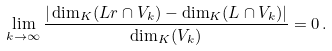Convert formula to latex. <formula><loc_0><loc_0><loc_500><loc_500>\lim _ { k \to \infty } \frac { | \dim _ { K } ( L r \cap V _ { k } ) - \dim _ { K } ( L \cap V _ { k } ) | } { \dim _ { K } ( V _ { k } ) } = 0 \, .</formula> 